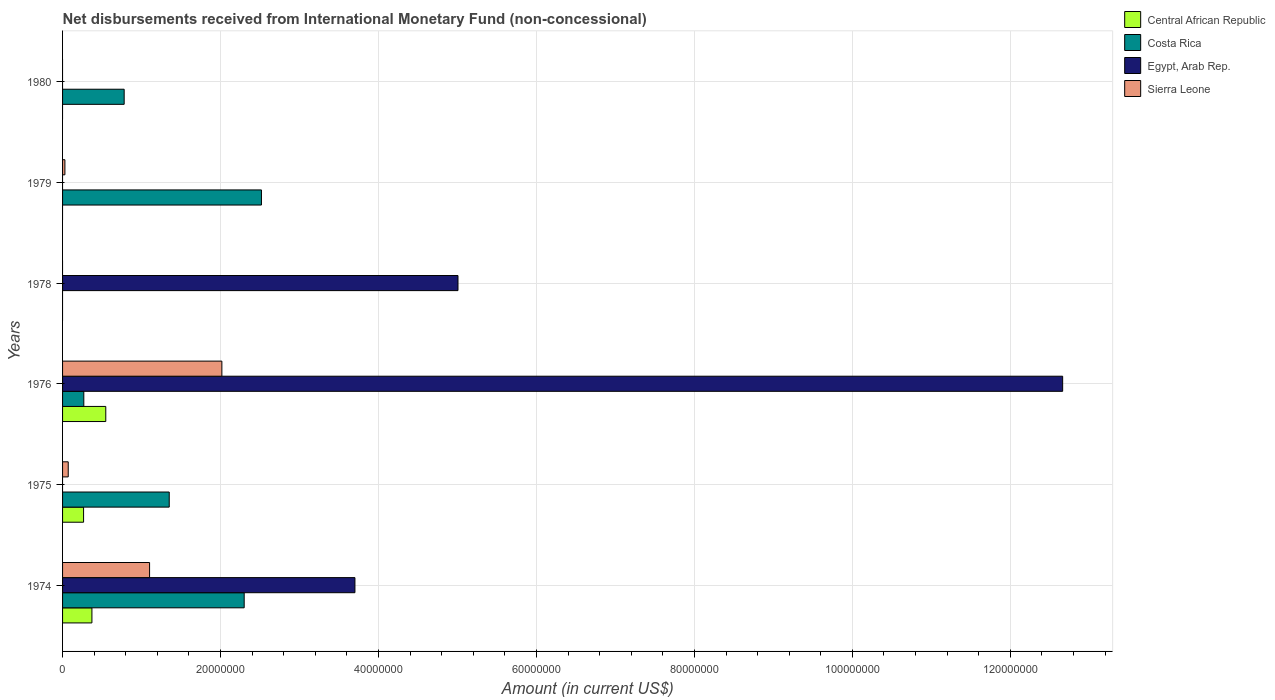How many different coloured bars are there?
Keep it short and to the point. 4. Are the number of bars on each tick of the Y-axis equal?
Provide a succinct answer. No. How many bars are there on the 5th tick from the top?
Provide a succinct answer. 3. What is the label of the 2nd group of bars from the top?
Provide a short and direct response. 1979. What is the amount of disbursements received from International Monetary Fund in Egypt, Arab Rep. in 1974?
Your answer should be very brief. 3.70e+07. Across all years, what is the maximum amount of disbursements received from International Monetary Fund in Costa Rica?
Offer a terse response. 2.52e+07. Across all years, what is the minimum amount of disbursements received from International Monetary Fund in Sierra Leone?
Ensure brevity in your answer.  0. In which year was the amount of disbursements received from International Monetary Fund in Costa Rica maximum?
Give a very brief answer. 1979. What is the total amount of disbursements received from International Monetary Fund in Costa Rica in the graph?
Give a very brief answer. 7.22e+07. What is the difference between the amount of disbursements received from International Monetary Fund in Costa Rica in 1974 and that in 1976?
Offer a very short reply. 2.03e+07. What is the difference between the amount of disbursements received from International Monetary Fund in Egypt, Arab Rep. in 1980 and the amount of disbursements received from International Monetary Fund in Central African Republic in 1978?
Keep it short and to the point. 0. What is the average amount of disbursements received from International Monetary Fund in Sierra Leone per year?
Give a very brief answer. 5.37e+06. In the year 1979, what is the difference between the amount of disbursements received from International Monetary Fund in Costa Rica and amount of disbursements received from International Monetary Fund in Sierra Leone?
Your answer should be very brief. 2.49e+07. What is the ratio of the amount of disbursements received from International Monetary Fund in Egypt, Arab Rep. in 1974 to that in 1976?
Provide a succinct answer. 0.29. Is the amount of disbursements received from International Monetary Fund in Sierra Leone in 1974 less than that in 1975?
Offer a terse response. No. What is the difference between the highest and the second highest amount of disbursements received from International Monetary Fund in Costa Rica?
Provide a short and direct response. 2.19e+06. What is the difference between the highest and the lowest amount of disbursements received from International Monetary Fund in Costa Rica?
Provide a succinct answer. 2.52e+07. Is it the case that in every year, the sum of the amount of disbursements received from International Monetary Fund in Egypt, Arab Rep. and amount of disbursements received from International Monetary Fund in Costa Rica is greater than the sum of amount of disbursements received from International Monetary Fund in Central African Republic and amount of disbursements received from International Monetary Fund in Sierra Leone?
Your answer should be very brief. No. What is the difference between two consecutive major ticks on the X-axis?
Ensure brevity in your answer.  2.00e+07. Does the graph contain grids?
Give a very brief answer. Yes. How are the legend labels stacked?
Offer a very short reply. Vertical. What is the title of the graph?
Your response must be concise. Net disbursements received from International Monetary Fund (non-concessional). What is the Amount (in current US$) of Central African Republic in 1974?
Keep it short and to the point. 3.72e+06. What is the Amount (in current US$) of Costa Rica in 1974?
Keep it short and to the point. 2.30e+07. What is the Amount (in current US$) of Egypt, Arab Rep. in 1974?
Your response must be concise. 3.70e+07. What is the Amount (in current US$) in Sierra Leone in 1974?
Provide a succinct answer. 1.10e+07. What is the Amount (in current US$) in Central African Republic in 1975?
Provide a succinct answer. 2.66e+06. What is the Amount (in current US$) in Costa Rica in 1975?
Offer a terse response. 1.35e+07. What is the Amount (in current US$) in Sierra Leone in 1975?
Your response must be concise. 7.17e+05. What is the Amount (in current US$) in Central African Republic in 1976?
Offer a very short reply. 5.47e+06. What is the Amount (in current US$) of Costa Rica in 1976?
Your answer should be very brief. 2.69e+06. What is the Amount (in current US$) in Egypt, Arab Rep. in 1976?
Provide a succinct answer. 1.27e+08. What is the Amount (in current US$) of Sierra Leone in 1976?
Provide a short and direct response. 2.02e+07. What is the Amount (in current US$) in Central African Republic in 1978?
Your answer should be compact. 0. What is the Amount (in current US$) in Costa Rica in 1978?
Provide a succinct answer. 0. What is the Amount (in current US$) of Egypt, Arab Rep. in 1978?
Provide a short and direct response. 5.01e+07. What is the Amount (in current US$) of Sierra Leone in 1978?
Your response must be concise. 0. What is the Amount (in current US$) of Costa Rica in 1979?
Your response must be concise. 2.52e+07. What is the Amount (in current US$) in Egypt, Arab Rep. in 1979?
Your response must be concise. 0. What is the Amount (in current US$) of Sierra Leone in 1979?
Provide a succinct answer. 2.97e+05. What is the Amount (in current US$) of Central African Republic in 1980?
Offer a terse response. 0. What is the Amount (in current US$) of Costa Rica in 1980?
Offer a very short reply. 7.80e+06. What is the Amount (in current US$) in Egypt, Arab Rep. in 1980?
Offer a very short reply. 0. What is the Amount (in current US$) of Sierra Leone in 1980?
Give a very brief answer. 0. Across all years, what is the maximum Amount (in current US$) of Central African Republic?
Give a very brief answer. 5.47e+06. Across all years, what is the maximum Amount (in current US$) in Costa Rica?
Provide a short and direct response. 2.52e+07. Across all years, what is the maximum Amount (in current US$) of Egypt, Arab Rep.?
Provide a short and direct response. 1.27e+08. Across all years, what is the maximum Amount (in current US$) of Sierra Leone?
Ensure brevity in your answer.  2.02e+07. Across all years, what is the minimum Amount (in current US$) in Costa Rica?
Your answer should be compact. 0. Across all years, what is the minimum Amount (in current US$) of Sierra Leone?
Provide a succinct answer. 0. What is the total Amount (in current US$) in Central African Republic in the graph?
Your response must be concise. 1.18e+07. What is the total Amount (in current US$) of Costa Rica in the graph?
Your answer should be very brief. 7.22e+07. What is the total Amount (in current US$) in Egypt, Arab Rep. in the graph?
Your answer should be compact. 2.14e+08. What is the total Amount (in current US$) in Sierra Leone in the graph?
Your response must be concise. 3.22e+07. What is the difference between the Amount (in current US$) of Central African Republic in 1974 and that in 1975?
Ensure brevity in your answer.  1.06e+06. What is the difference between the Amount (in current US$) in Costa Rica in 1974 and that in 1975?
Give a very brief answer. 9.49e+06. What is the difference between the Amount (in current US$) in Sierra Leone in 1974 and that in 1975?
Your answer should be very brief. 1.03e+07. What is the difference between the Amount (in current US$) in Central African Republic in 1974 and that in 1976?
Provide a short and direct response. -1.76e+06. What is the difference between the Amount (in current US$) in Costa Rica in 1974 and that in 1976?
Your answer should be compact. 2.03e+07. What is the difference between the Amount (in current US$) in Egypt, Arab Rep. in 1974 and that in 1976?
Provide a succinct answer. -8.96e+07. What is the difference between the Amount (in current US$) of Sierra Leone in 1974 and that in 1976?
Offer a terse response. -9.15e+06. What is the difference between the Amount (in current US$) of Egypt, Arab Rep. in 1974 and that in 1978?
Ensure brevity in your answer.  -1.30e+07. What is the difference between the Amount (in current US$) in Costa Rica in 1974 and that in 1979?
Provide a succinct answer. -2.19e+06. What is the difference between the Amount (in current US$) of Sierra Leone in 1974 and that in 1979?
Provide a short and direct response. 1.07e+07. What is the difference between the Amount (in current US$) of Costa Rica in 1974 and that in 1980?
Offer a very short reply. 1.52e+07. What is the difference between the Amount (in current US$) in Central African Republic in 1975 and that in 1976?
Your answer should be compact. -2.81e+06. What is the difference between the Amount (in current US$) of Costa Rica in 1975 and that in 1976?
Your response must be concise. 1.08e+07. What is the difference between the Amount (in current US$) of Sierra Leone in 1975 and that in 1976?
Offer a terse response. -1.95e+07. What is the difference between the Amount (in current US$) in Costa Rica in 1975 and that in 1979?
Offer a very short reply. -1.17e+07. What is the difference between the Amount (in current US$) of Sierra Leone in 1975 and that in 1979?
Provide a succinct answer. 4.20e+05. What is the difference between the Amount (in current US$) of Costa Rica in 1975 and that in 1980?
Provide a succinct answer. 5.71e+06. What is the difference between the Amount (in current US$) of Egypt, Arab Rep. in 1976 and that in 1978?
Offer a terse response. 7.66e+07. What is the difference between the Amount (in current US$) in Costa Rica in 1976 and that in 1979?
Make the answer very short. -2.25e+07. What is the difference between the Amount (in current US$) in Sierra Leone in 1976 and that in 1979?
Ensure brevity in your answer.  1.99e+07. What is the difference between the Amount (in current US$) in Costa Rica in 1976 and that in 1980?
Your answer should be very brief. -5.11e+06. What is the difference between the Amount (in current US$) of Costa Rica in 1979 and that in 1980?
Ensure brevity in your answer.  1.74e+07. What is the difference between the Amount (in current US$) in Central African Republic in 1974 and the Amount (in current US$) in Costa Rica in 1975?
Give a very brief answer. -9.79e+06. What is the difference between the Amount (in current US$) of Costa Rica in 1974 and the Amount (in current US$) of Sierra Leone in 1975?
Offer a terse response. 2.23e+07. What is the difference between the Amount (in current US$) in Egypt, Arab Rep. in 1974 and the Amount (in current US$) in Sierra Leone in 1975?
Keep it short and to the point. 3.63e+07. What is the difference between the Amount (in current US$) in Central African Republic in 1974 and the Amount (in current US$) in Costa Rica in 1976?
Provide a succinct answer. 1.03e+06. What is the difference between the Amount (in current US$) of Central African Republic in 1974 and the Amount (in current US$) of Egypt, Arab Rep. in 1976?
Keep it short and to the point. -1.23e+08. What is the difference between the Amount (in current US$) of Central African Republic in 1974 and the Amount (in current US$) of Sierra Leone in 1976?
Provide a short and direct response. -1.65e+07. What is the difference between the Amount (in current US$) in Costa Rica in 1974 and the Amount (in current US$) in Egypt, Arab Rep. in 1976?
Offer a terse response. -1.04e+08. What is the difference between the Amount (in current US$) in Costa Rica in 1974 and the Amount (in current US$) in Sierra Leone in 1976?
Provide a succinct answer. 2.83e+06. What is the difference between the Amount (in current US$) in Egypt, Arab Rep. in 1974 and the Amount (in current US$) in Sierra Leone in 1976?
Your response must be concise. 1.68e+07. What is the difference between the Amount (in current US$) in Central African Republic in 1974 and the Amount (in current US$) in Egypt, Arab Rep. in 1978?
Make the answer very short. -4.63e+07. What is the difference between the Amount (in current US$) of Costa Rica in 1974 and the Amount (in current US$) of Egypt, Arab Rep. in 1978?
Ensure brevity in your answer.  -2.71e+07. What is the difference between the Amount (in current US$) of Central African Republic in 1974 and the Amount (in current US$) of Costa Rica in 1979?
Provide a succinct answer. -2.15e+07. What is the difference between the Amount (in current US$) of Central African Republic in 1974 and the Amount (in current US$) of Sierra Leone in 1979?
Offer a terse response. 3.42e+06. What is the difference between the Amount (in current US$) in Costa Rica in 1974 and the Amount (in current US$) in Sierra Leone in 1979?
Your response must be concise. 2.27e+07. What is the difference between the Amount (in current US$) of Egypt, Arab Rep. in 1974 and the Amount (in current US$) of Sierra Leone in 1979?
Your answer should be very brief. 3.67e+07. What is the difference between the Amount (in current US$) in Central African Republic in 1974 and the Amount (in current US$) in Costa Rica in 1980?
Offer a very short reply. -4.08e+06. What is the difference between the Amount (in current US$) of Central African Republic in 1975 and the Amount (in current US$) of Costa Rica in 1976?
Your answer should be compact. -3.10e+04. What is the difference between the Amount (in current US$) of Central African Republic in 1975 and the Amount (in current US$) of Egypt, Arab Rep. in 1976?
Provide a succinct answer. -1.24e+08. What is the difference between the Amount (in current US$) of Central African Republic in 1975 and the Amount (in current US$) of Sierra Leone in 1976?
Make the answer very short. -1.75e+07. What is the difference between the Amount (in current US$) of Costa Rica in 1975 and the Amount (in current US$) of Egypt, Arab Rep. in 1976?
Your response must be concise. -1.13e+08. What is the difference between the Amount (in current US$) in Costa Rica in 1975 and the Amount (in current US$) in Sierra Leone in 1976?
Offer a terse response. -6.66e+06. What is the difference between the Amount (in current US$) of Central African Republic in 1975 and the Amount (in current US$) of Egypt, Arab Rep. in 1978?
Provide a short and direct response. -4.74e+07. What is the difference between the Amount (in current US$) in Costa Rica in 1975 and the Amount (in current US$) in Egypt, Arab Rep. in 1978?
Ensure brevity in your answer.  -3.66e+07. What is the difference between the Amount (in current US$) in Central African Republic in 1975 and the Amount (in current US$) in Costa Rica in 1979?
Give a very brief answer. -2.25e+07. What is the difference between the Amount (in current US$) of Central African Republic in 1975 and the Amount (in current US$) of Sierra Leone in 1979?
Provide a succinct answer. 2.36e+06. What is the difference between the Amount (in current US$) in Costa Rica in 1975 and the Amount (in current US$) in Sierra Leone in 1979?
Provide a short and direct response. 1.32e+07. What is the difference between the Amount (in current US$) of Central African Republic in 1975 and the Amount (in current US$) of Costa Rica in 1980?
Keep it short and to the point. -5.14e+06. What is the difference between the Amount (in current US$) of Central African Republic in 1976 and the Amount (in current US$) of Egypt, Arab Rep. in 1978?
Provide a short and direct response. -4.46e+07. What is the difference between the Amount (in current US$) in Costa Rica in 1976 and the Amount (in current US$) in Egypt, Arab Rep. in 1978?
Provide a succinct answer. -4.74e+07. What is the difference between the Amount (in current US$) of Central African Republic in 1976 and the Amount (in current US$) of Costa Rica in 1979?
Make the answer very short. -1.97e+07. What is the difference between the Amount (in current US$) in Central African Republic in 1976 and the Amount (in current US$) in Sierra Leone in 1979?
Make the answer very short. 5.18e+06. What is the difference between the Amount (in current US$) in Costa Rica in 1976 and the Amount (in current US$) in Sierra Leone in 1979?
Keep it short and to the point. 2.39e+06. What is the difference between the Amount (in current US$) in Egypt, Arab Rep. in 1976 and the Amount (in current US$) in Sierra Leone in 1979?
Your answer should be compact. 1.26e+08. What is the difference between the Amount (in current US$) of Central African Republic in 1976 and the Amount (in current US$) of Costa Rica in 1980?
Provide a short and direct response. -2.33e+06. What is the difference between the Amount (in current US$) of Egypt, Arab Rep. in 1978 and the Amount (in current US$) of Sierra Leone in 1979?
Your answer should be very brief. 4.98e+07. What is the average Amount (in current US$) in Central African Republic per year?
Keep it short and to the point. 1.97e+06. What is the average Amount (in current US$) in Costa Rica per year?
Give a very brief answer. 1.20e+07. What is the average Amount (in current US$) in Egypt, Arab Rep. per year?
Offer a terse response. 3.56e+07. What is the average Amount (in current US$) in Sierra Leone per year?
Your response must be concise. 5.37e+06. In the year 1974, what is the difference between the Amount (in current US$) of Central African Republic and Amount (in current US$) of Costa Rica?
Your response must be concise. -1.93e+07. In the year 1974, what is the difference between the Amount (in current US$) of Central African Republic and Amount (in current US$) of Egypt, Arab Rep.?
Your answer should be compact. -3.33e+07. In the year 1974, what is the difference between the Amount (in current US$) in Central African Republic and Amount (in current US$) in Sierra Leone?
Ensure brevity in your answer.  -7.30e+06. In the year 1974, what is the difference between the Amount (in current US$) in Costa Rica and Amount (in current US$) in Egypt, Arab Rep.?
Give a very brief answer. -1.40e+07. In the year 1974, what is the difference between the Amount (in current US$) of Costa Rica and Amount (in current US$) of Sierra Leone?
Provide a short and direct response. 1.20e+07. In the year 1974, what is the difference between the Amount (in current US$) of Egypt, Arab Rep. and Amount (in current US$) of Sierra Leone?
Offer a terse response. 2.60e+07. In the year 1975, what is the difference between the Amount (in current US$) of Central African Republic and Amount (in current US$) of Costa Rica?
Your answer should be very brief. -1.08e+07. In the year 1975, what is the difference between the Amount (in current US$) of Central African Republic and Amount (in current US$) of Sierra Leone?
Provide a short and direct response. 1.94e+06. In the year 1975, what is the difference between the Amount (in current US$) in Costa Rica and Amount (in current US$) in Sierra Leone?
Your response must be concise. 1.28e+07. In the year 1976, what is the difference between the Amount (in current US$) in Central African Republic and Amount (in current US$) in Costa Rica?
Give a very brief answer. 2.78e+06. In the year 1976, what is the difference between the Amount (in current US$) in Central African Republic and Amount (in current US$) in Egypt, Arab Rep.?
Provide a short and direct response. -1.21e+08. In the year 1976, what is the difference between the Amount (in current US$) of Central African Republic and Amount (in current US$) of Sierra Leone?
Your response must be concise. -1.47e+07. In the year 1976, what is the difference between the Amount (in current US$) in Costa Rica and Amount (in current US$) in Egypt, Arab Rep.?
Keep it short and to the point. -1.24e+08. In the year 1976, what is the difference between the Amount (in current US$) of Costa Rica and Amount (in current US$) of Sierra Leone?
Provide a succinct answer. -1.75e+07. In the year 1976, what is the difference between the Amount (in current US$) in Egypt, Arab Rep. and Amount (in current US$) in Sierra Leone?
Your answer should be very brief. 1.06e+08. In the year 1979, what is the difference between the Amount (in current US$) in Costa Rica and Amount (in current US$) in Sierra Leone?
Offer a very short reply. 2.49e+07. What is the ratio of the Amount (in current US$) of Central African Republic in 1974 to that in 1975?
Your response must be concise. 1.4. What is the ratio of the Amount (in current US$) of Costa Rica in 1974 to that in 1975?
Offer a very short reply. 1.7. What is the ratio of the Amount (in current US$) of Sierra Leone in 1974 to that in 1975?
Make the answer very short. 15.36. What is the ratio of the Amount (in current US$) in Central African Republic in 1974 to that in 1976?
Offer a terse response. 0.68. What is the ratio of the Amount (in current US$) of Costa Rica in 1974 to that in 1976?
Give a very brief answer. 8.55. What is the ratio of the Amount (in current US$) of Egypt, Arab Rep. in 1974 to that in 1976?
Make the answer very short. 0.29. What is the ratio of the Amount (in current US$) in Sierra Leone in 1974 to that in 1976?
Offer a terse response. 0.55. What is the ratio of the Amount (in current US$) of Egypt, Arab Rep. in 1974 to that in 1978?
Provide a short and direct response. 0.74. What is the ratio of the Amount (in current US$) in Costa Rica in 1974 to that in 1979?
Offer a terse response. 0.91. What is the ratio of the Amount (in current US$) of Sierra Leone in 1974 to that in 1979?
Your response must be concise. 37.09. What is the ratio of the Amount (in current US$) of Costa Rica in 1974 to that in 1980?
Your response must be concise. 2.95. What is the ratio of the Amount (in current US$) of Central African Republic in 1975 to that in 1976?
Make the answer very short. 0.49. What is the ratio of the Amount (in current US$) in Costa Rica in 1975 to that in 1976?
Your response must be concise. 5.02. What is the ratio of the Amount (in current US$) of Sierra Leone in 1975 to that in 1976?
Offer a very short reply. 0.04. What is the ratio of the Amount (in current US$) of Costa Rica in 1975 to that in 1979?
Your answer should be very brief. 0.54. What is the ratio of the Amount (in current US$) of Sierra Leone in 1975 to that in 1979?
Your answer should be very brief. 2.41. What is the ratio of the Amount (in current US$) in Costa Rica in 1975 to that in 1980?
Provide a short and direct response. 1.73. What is the ratio of the Amount (in current US$) in Egypt, Arab Rep. in 1976 to that in 1978?
Give a very brief answer. 2.53. What is the ratio of the Amount (in current US$) in Costa Rica in 1976 to that in 1979?
Your answer should be very brief. 0.11. What is the ratio of the Amount (in current US$) in Sierra Leone in 1976 to that in 1979?
Ensure brevity in your answer.  67.91. What is the ratio of the Amount (in current US$) in Costa Rica in 1976 to that in 1980?
Make the answer very short. 0.34. What is the ratio of the Amount (in current US$) of Costa Rica in 1979 to that in 1980?
Offer a very short reply. 3.23. What is the difference between the highest and the second highest Amount (in current US$) in Central African Republic?
Your response must be concise. 1.76e+06. What is the difference between the highest and the second highest Amount (in current US$) in Costa Rica?
Ensure brevity in your answer.  2.19e+06. What is the difference between the highest and the second highest Amount (in current US$) in Egypt, Arab Rep.?
Make the answer very short. 7.66e+07. What is the difference between the highest and the second highest Amount (in current US$) of Sierra Leone?
Your response must be concise. 9.15e+06. What is the difference between the highest and the lowest Amount (in current US$) of Central African Republic?
Give a very brief answer. 5.47e+06. What is the difference between the highest and the lowest Amount (in current US$) of Costa Rica?
Give a very brief answer. 2.52e+07. What is the difference between the highest and the lowest Amount (in current US$) in Egypt, Arab Rep.?
Ensure brevity in your answer.  1.27e+08. What is the difference between the highest and the lowest Amount (in current US$) of Sierra Leone?
Keep it short and to the point. 2.02e+07. 